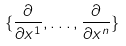Convert formula to latex. <formula><loc_0><loc_0><loc_500><loc_500>\{ \frac { \partial } { \partial x ^ { 1 } } , \dots , \frac { \partial } { \partial x ^ { n } } \}</formula> 